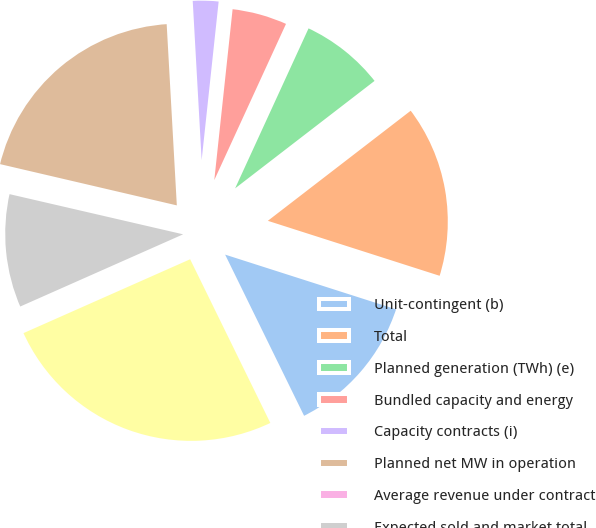Convert chart to OTSL. <chart><loc_0><loc_0><loc_500><loc_500><pie_chart><fcel>Unit-contingent (b)<fcel>Total<fcel>Planned generation (TWh) (e)<fcel>Bundled capacity and energy<fcel>Capacity contracts (i)<fcel>Planned net MW in operation<fcel>Average revenue under contract<fcel>Expected sold and market total<fcel>Sensitivity -/+ 10 per MWh<nl><fcel>12.82%<fcel>15.38%<fcel>7.7%<fcel>5.15%<fcel>2.59%<fcel>20.46%<fcel>0.03%<fcel>10.26%<fcel>25.61%<nl></chart> 